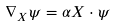<formula> <loc_0><loc_0><loc_500><loc_500>\nabla _ { X } \psi = \alpha X \cdot \psi</formula> 